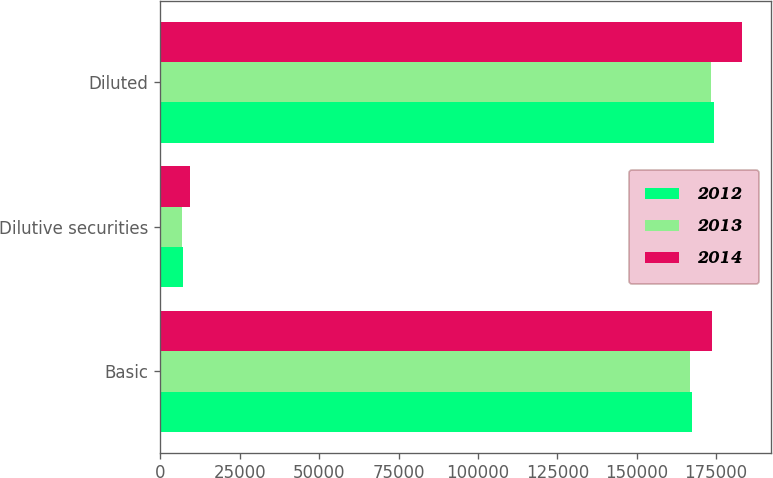Convert chart. <chart><loc_0><loc_0><loc_500><loc_500><stacked_bar_chart><ecel><fcel>Basic<fcel>Dilutive securities<fcel>Diluted<nl><fcel>2012<fcel>167257<fcel>7028<fcel>174285<nl><fcel>2013<fcel>166679<fcel>6708<fcel>173387<nl><fcel>2014<fcel>173712<fcel>9371<fcel>183083<nl></chart> 